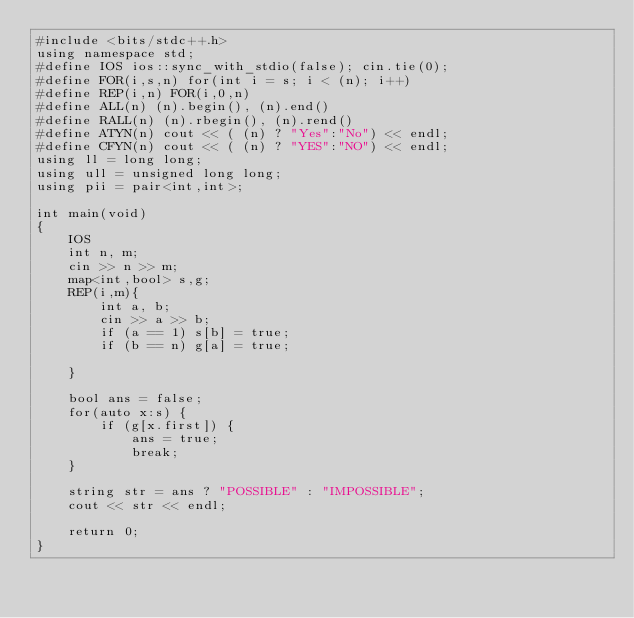Convert code to text. <code><loc_0><loc_0><loc_500><loc_500><_C++_>#include <bits/stdc++.h>
using namespace std;
#define IOS ios::sync_with_stdio(false); cin.tie(0);
#define FOR(i,s,n) for(int i = s; i < (n); i++)
#define REP(i,n) FOR(i,0,n)
#define ALL(n) (n).begin(), (n).end()
#define RALL(n) (n).rbegin(), (n).rend()
#define ATYN(n) cout << ( (n) ? "Yes":"No") << endl;
#define CFYN(n) cout << ( (n) ? "YES":"NO") << endl;
using ll = long long;
using ull = unsigned long long;
using pii = pair<int,int>;

int main(void)
{
    IOS
    int n, m;
    cin >> n >> m;
    map<int,bool> s,g;
    REP(i,m){
        int a, b;
        cin >> a >> b;
        if (a == 1) s[b] = true;
        if (b == n) g[a] = true;

    }

    bool ans = false;
    for(auto x:s) {
        if (g[x.first]) {
            ans = true;
            break;
    }

    string str = ans ? "POSSIBLE" : "IMPOSSIBLE";
    cout << str << endl;

    return 0;
}</code> 